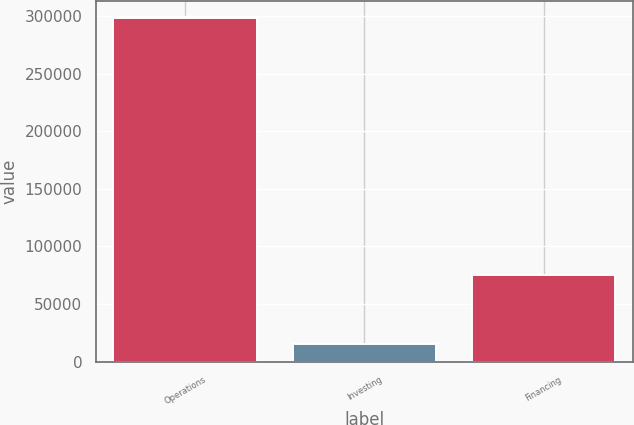Convert chart to OTSL. <chart><loc_0><loc_0><loc_500><loc_500><bar_chart><fcel>Operations<fcel>Investing<fcel>Financing<nl><fcel>298460<fcel>15594<fcel>75589<nl></chart> 